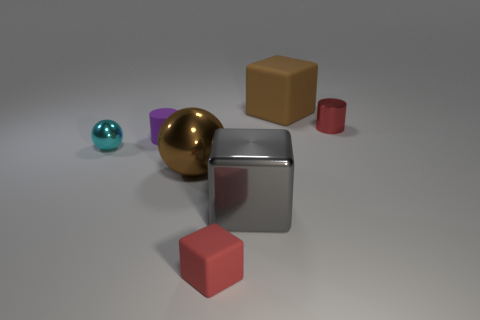There is a large thing that is behind the small purple rubber object; does it have the same shape as the tiny red object in front of the matte cylinder?
Ensure brevity in your answer.  Yes. There is a large metallic thing that is right of the large metallic sphere; is there a large gray metal cube in front of it?
Ensure brevity in your answer.  No. Are any cyan cylinders visible?
Provide a succinct answer. No. How many red metal cylinders are the same size as the cyan shiny thing?
Your answer should be very brief. 1. How many rubber objects are on the right side of the big shiny ball and in front of the brown matte thing?
Make the answer very short. 1. Is the size of the brown object that is to the left of the gray thing the same as the brown matte cube?
Your answer should be compact. Yes. Are there any big spheres that have the same color as the tiny ball?
Make the answer very short. No. There is a brown object that is made of the same material as the cyan object; what is its size?
Offer a very short reply. Large. Are there more tiny metallic cylinders that are in front of the tiny purple rubber object than small cyan spheres in front of the cyan sphere?
Your answer should be compact. No. What number of other things are there of the same material as the big brown ball
Provide a short and direct response. 3. 